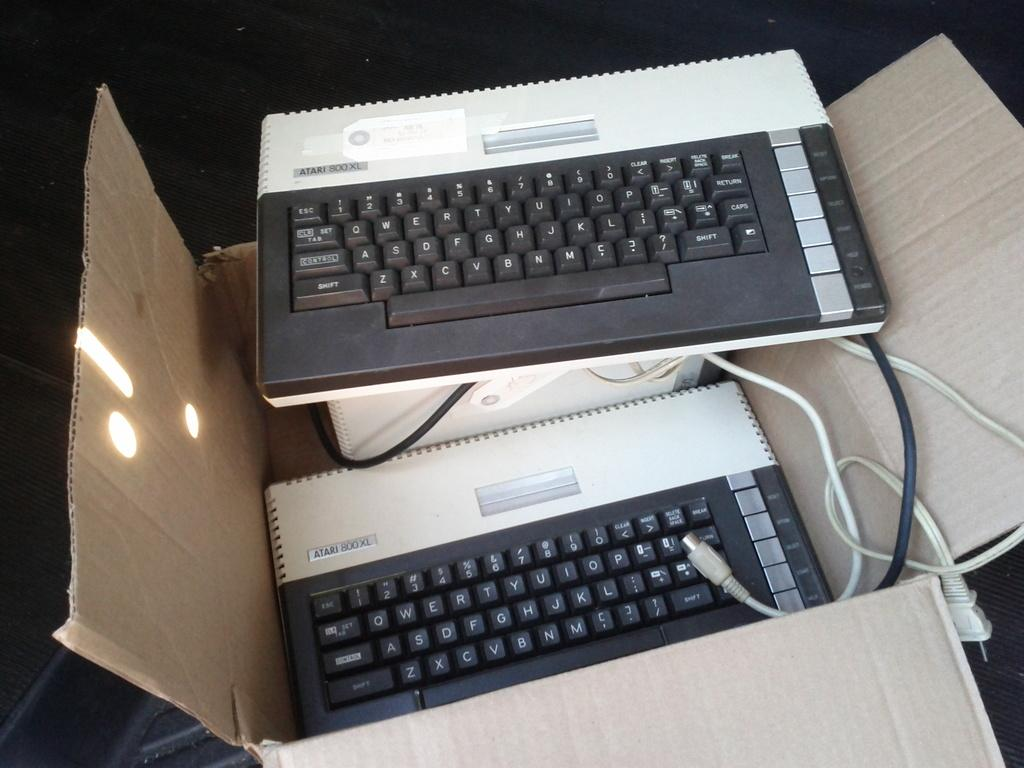Provide a one-sentence caption for the provided image. Two Atari 800 keyboards, one in a box and one on top of the box. 